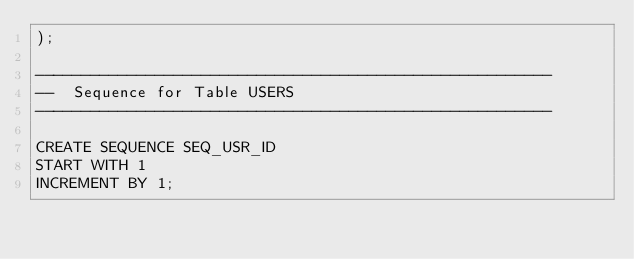Convert code to text. <code><loc_0><loc_0><loc_500><loc_500><_SQL_>);

--------------------------------------------------------
--  Sequence for Table USERS
--------------------------------------------------------

CREATE SEQUENCE SEQ_USR_ID
START WITH 1
INCREMENT BY 1;</code> 